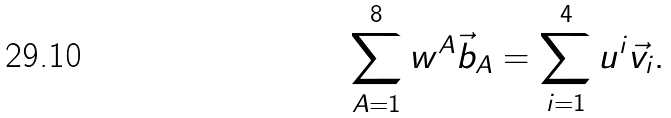Convert formula to latex. <formula><loc_0><loc_0><loc_500><loc_500>\sum _ { A = 1 } ^ { 8 } w ^ { A } \vec { b } _ { A } = \sum _ { i = 1 } ^ { 4 } u ^ { i } \vec { v } _ { i } .</formula> 